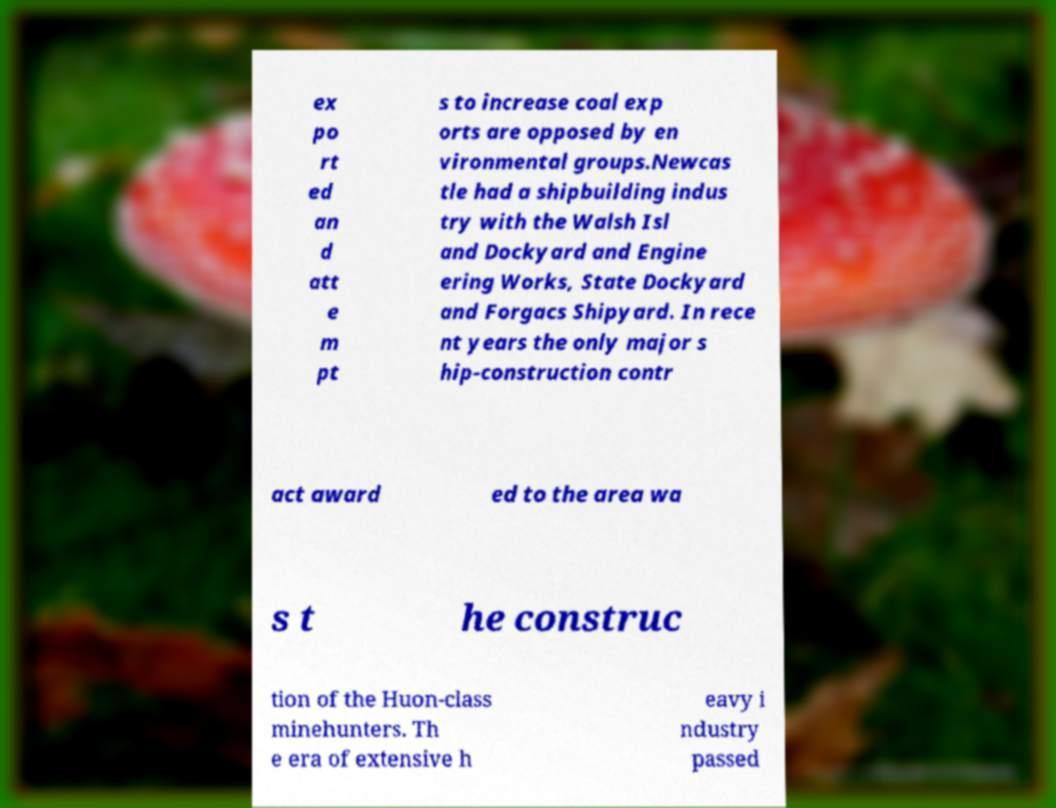There's text embedded in this image that I need extracted. Can you transcribe it verbatim? ex po rt ed an d att e m pt s to increase coal exp orts are opposed by en vironmental groups.Newcas tle had a shipbuilding indus try with the Walsh Isl and Dockyard and Engine ering Works, State Dockyard and Forgacs Shipyard. In rece nt years the only major s hip-construction contr act award ed to the area wa s t he construc tion of the Huon-class minehunters. Th e era of extensive h eavy i ndustry passed 